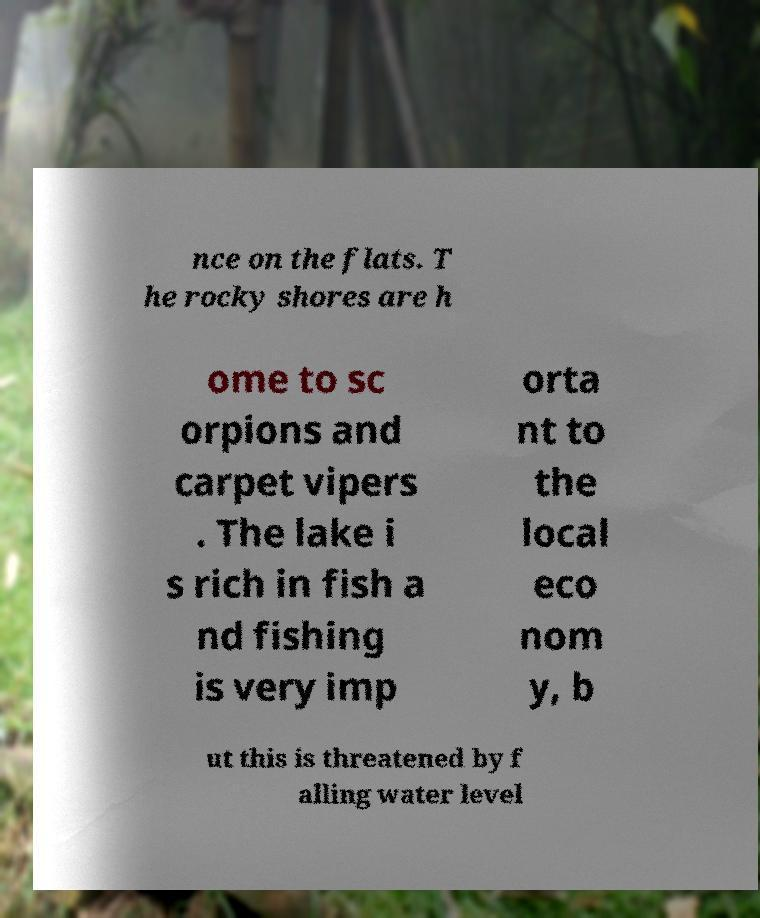Please identify and transcribe the text found in this image. nce on the flats. T he rocky shores are h ome to sc orpions and carpet vipers . The lake i s rich in fish a nd fishing is very imp orta nt to the local eco nom y, b ut this is threatened by f alling water level 